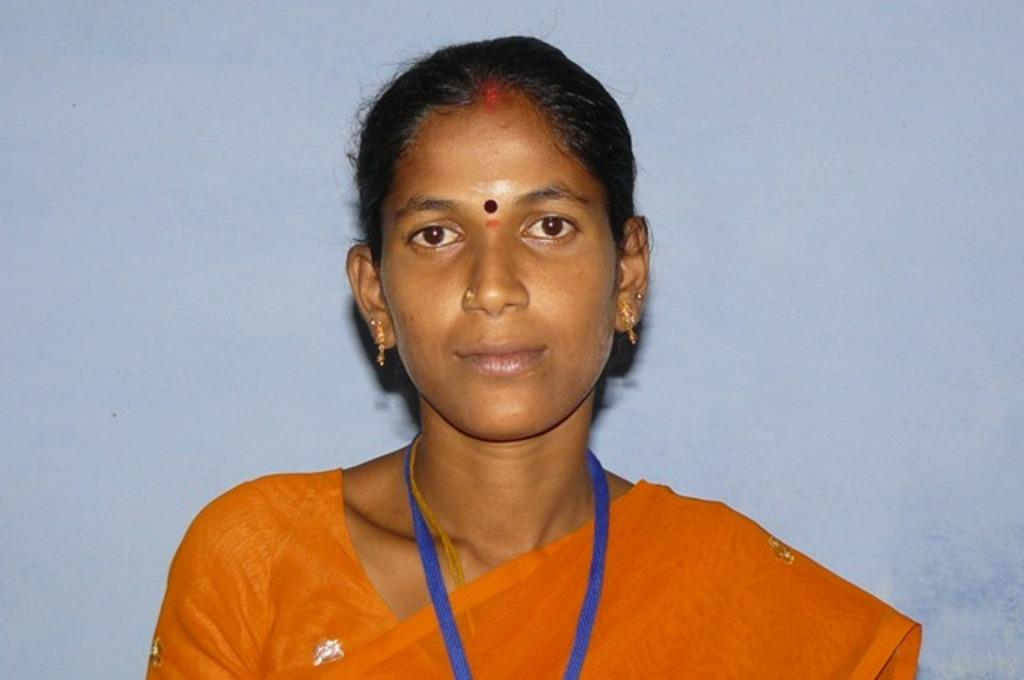Who or what is the main subject in the image? There is a person in the image. What is the person wearing? The person is wearing an orange color saree. What color is the background of the image? The background of the image is white. How many grapes can be seen on the person's saree in the image? There are no grapes visible on the person's saree in the image. What type of insect is crawling on the person's saree in the image? There are no insects, such as ladybugs, visible on the person's saree in the image. 